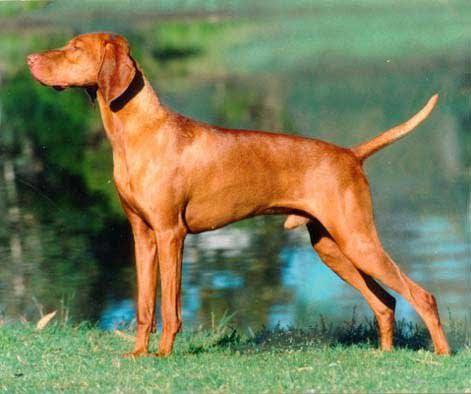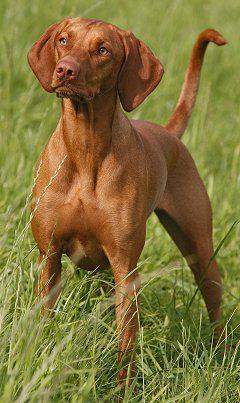The first image is the image on the left, the second image is the image on the right. Evaluate the accuracy of this statement regarding the images: "The dog in the image on the left is wearing a collar.". Is it true? Answer yes or no. No. The first image is the image on the left, the second image is the image on the right. Analyze the images presented: Is the assertion "The left image features a solid-colored hound in leftward-facing profile with its tail extended out." valid? Answer yes or no. Yes. 